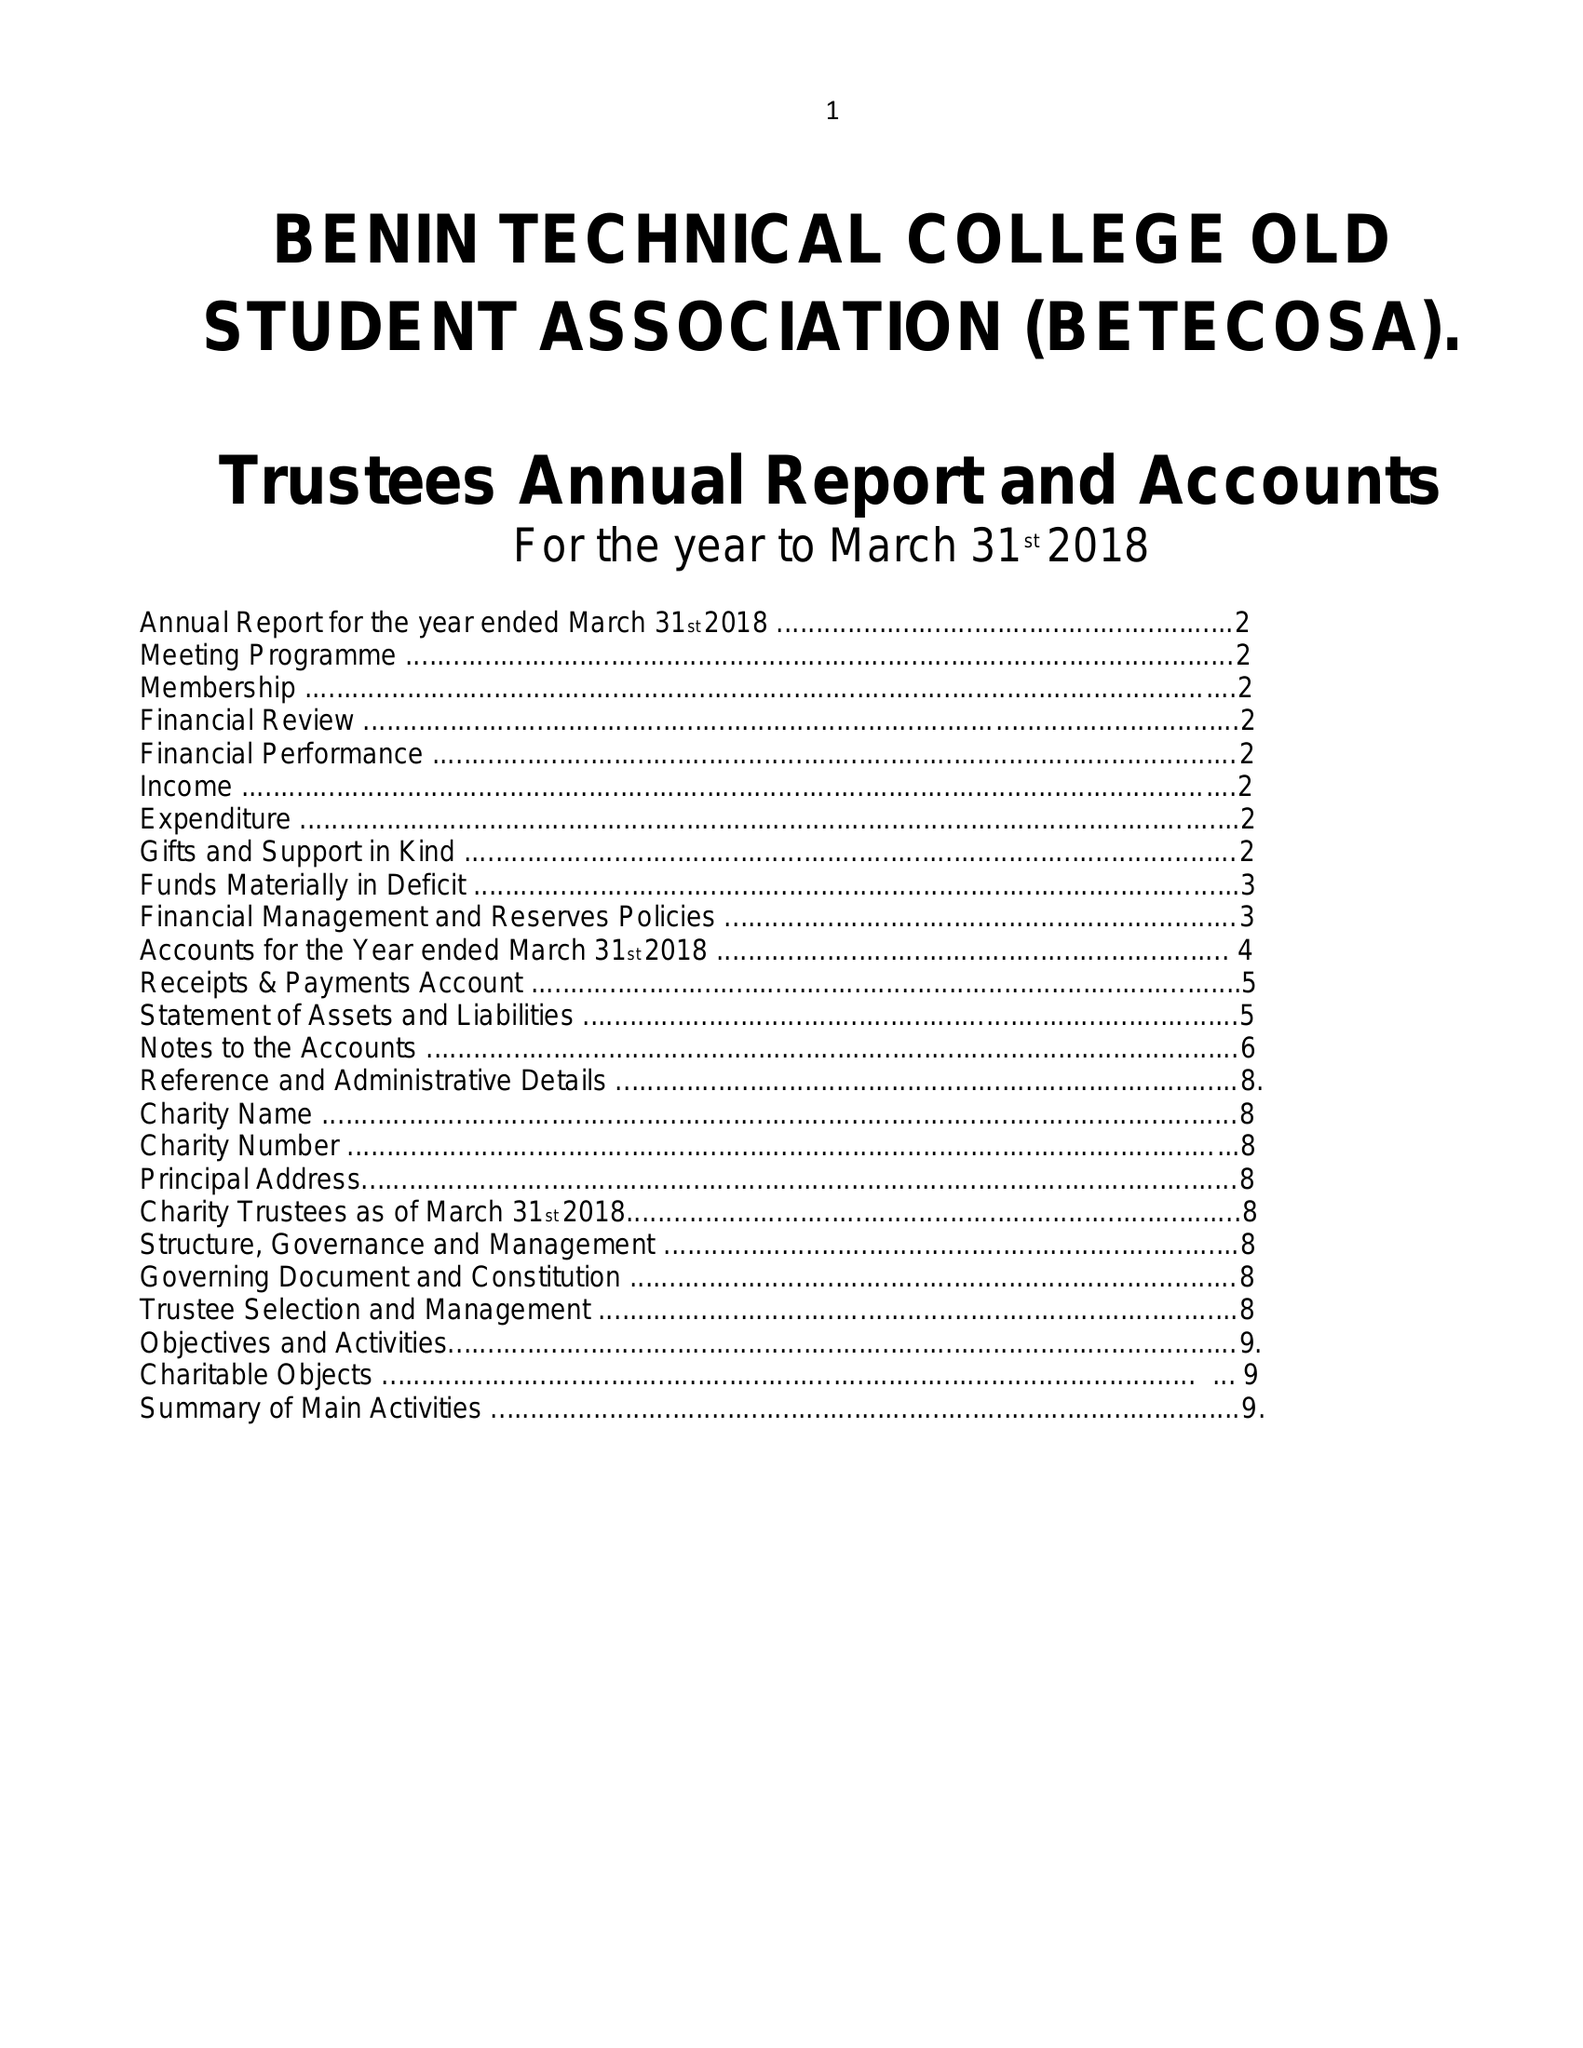What is the value for the income_annually_in_british_pounds?
Answer the question using a single word or phrase. 14698.00 